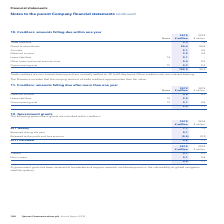According to Spirent Communications Plc's financial document, What terms are trade creditors normally settled on? According to the financial document, 30 to 60-day terms. The relevant text states: "non-interest bearing and are normally settled on 30 to 60-day terms. Other creditors are non-interest bearing...." Also, What is the value of deferred income in 2019? According to the financial document, 3.2 (in millions). The relevant text states: "Deferred income 3.2 4.4..." Also, What types of creditors are non-interest bearing? The document shows two values: Trade creditors and Other creditors. From the document: "g and are normally settled on 30 to 60-day terms. Other creditors are non-interest bearing. Trade creditors 2.3 1.4..." Additionally, In which year was the amount of Accruals larger? According to the financial document, 2019. The relevant text states: "180 Spirent Communications plc Annual Report 2019..." Also, can you calculate: What was the change in Accruals? Based on the calculation: 5.1-4.5, the result is 0.6 (in millions). This is based on the information: "Accruals 5.1 4.5 Accruals 5.1 4.5..." The key data points involved are: 4.5, 5.1. Also, can you calculate: What was the percentage change in Accruals? To answer this question, I need to perform calculations using the financial data. The calculation is: (5.1-4.5)/4.5, which equals 13.33 (percentage). This is based on the information: "Accruals 5.1 4.5 Accruals 5.1 4.5..." The key data points involved are: 4.5, 5.1. 